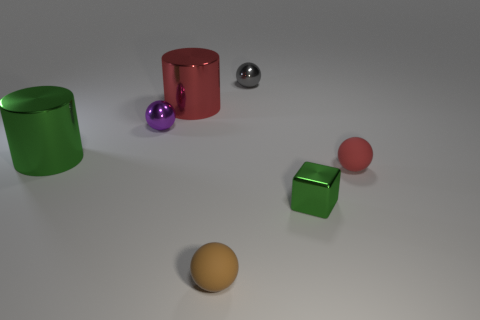Add 1 tiny purple metal objects. How many objects exist? 8 Subtract all cylinders. How many objects are left? 5 Subtract 0 blue balls. How many objects are left? 7 Subtract all green metallic objects. Subtract all large red shiny cylinders. How many objects are left? 4 Add 4 purple metallic objects. How many purple metallic objects are left? 5 Add 3 tiny blue spheres. How many tiny blue spheres exist? 3 